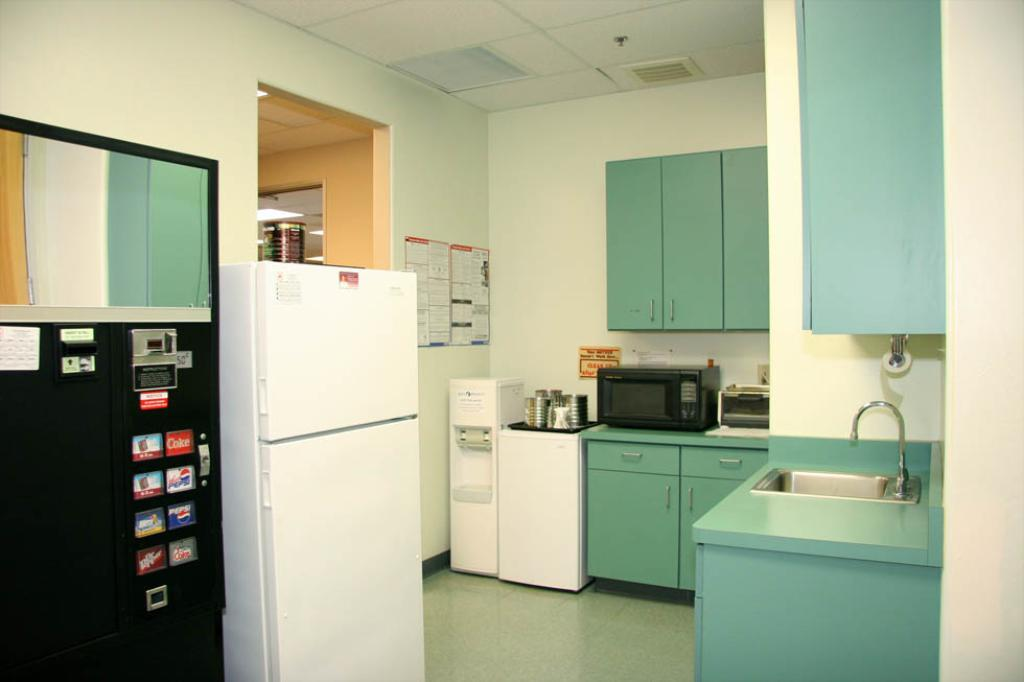Provide a one-sentence caption for the provided image. A kitchen that has a white refrigerator and a black vending machine that sells Pepsi. 